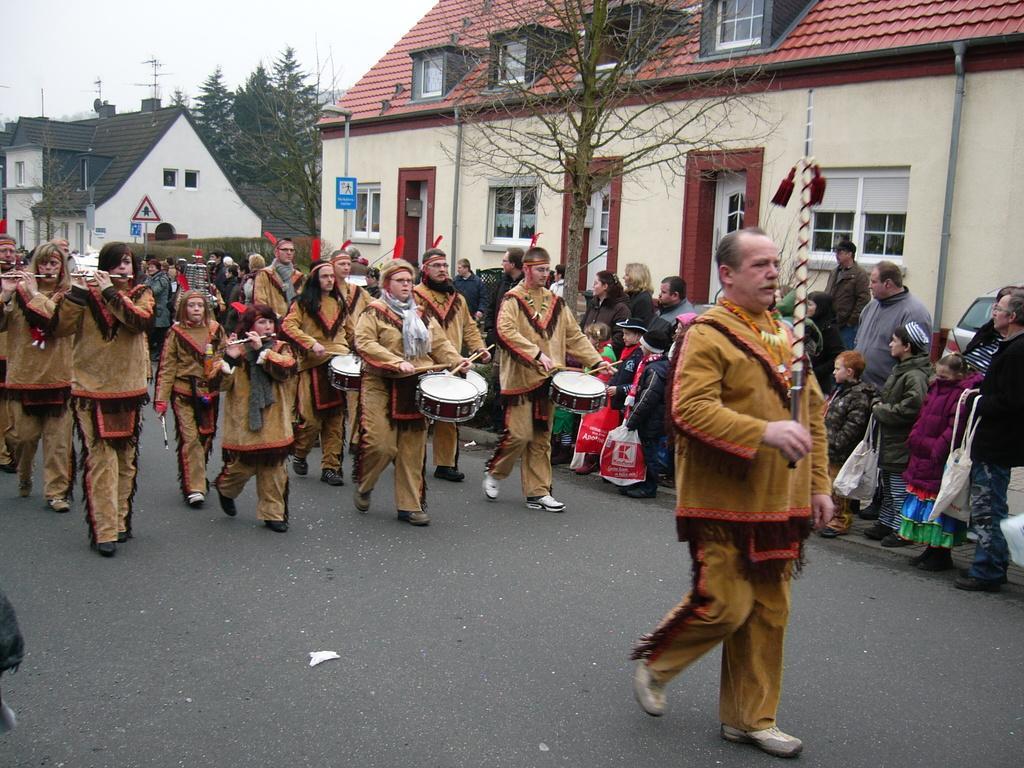Can you describe this image briefly? In this picture there are group of people who are playing musical instruments. There are few people who are standing to the right side. There is a house, signboard, streetlight, trees are seen in the background. 